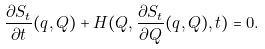<formula> <loc_0><loc_0><loc_500><loc_500>\frac { \partial S _ { t } } { \partial t } ( q , Q ) + H ( Q , \frac { \partial S _ { t } } { \partial Q } ( q , Q ) , t ) = 0 .</formula> 